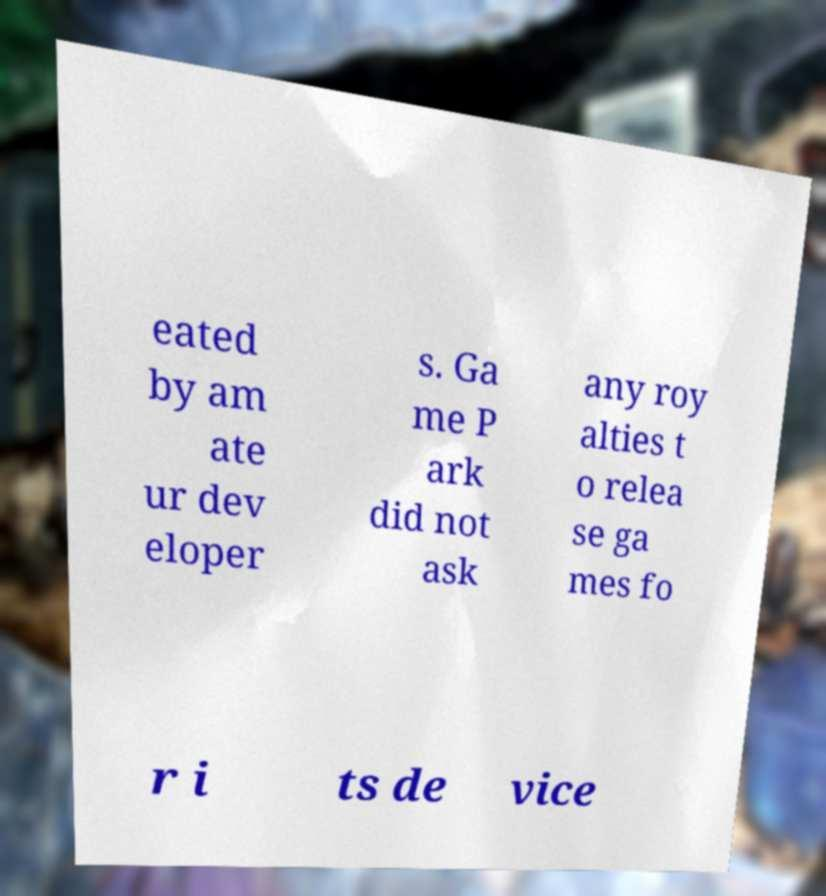For documentation purposes, I need the text within this image transcribed. Could you provide that? eated by am ate ur dev eloper s. Ga me P ark did not ask any roy alties t o relea se ga mes fo r i ts de vice 